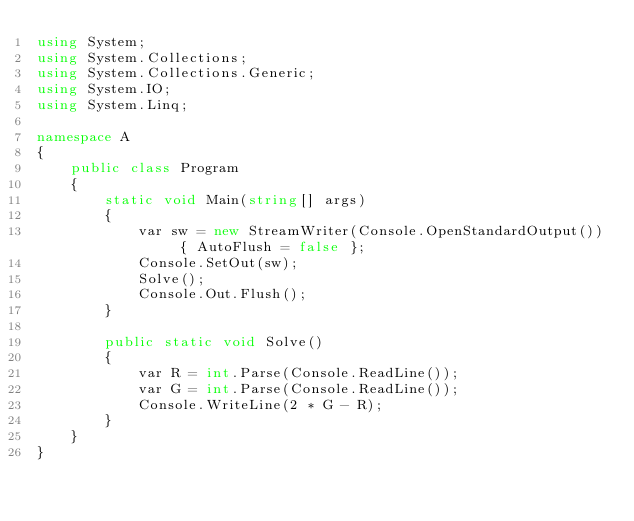<code> <loc_0><loc_0><loc_500><loc_500><_C#_>using System;
using System.Collections;
using System.Collections.Generic;
using System.IO;
using System.Linq;

namespace A
{
    public class Program
    {
        static void Main(string[] args)
        {
            var sw = new StreamWriter(Console.OpenStandardOutput()) { AutoFlush = false };
            Console.SetOut(sw);
            Solve();
            Console.Out.Flush();
        }

        public static void Solve()
        {
            var R = int.Parse(Console.ReadLine());
            var G = int.Parse(Console.ReadLine());
            Console.WriteLine(2 * G - R);
        }
    }
}
</code> 